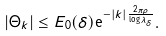Convert formula to latex. <formula><loc_0><loc_0><loc_500><loc_500>\left | \Theta _ { k } \right | \leq E _ { 0 } ( \delta ) \mathrm e ^ { - \left | k \right | \frac { 2 \pi \rho } { \log \lambda _ { \delta } } } .</formula> 